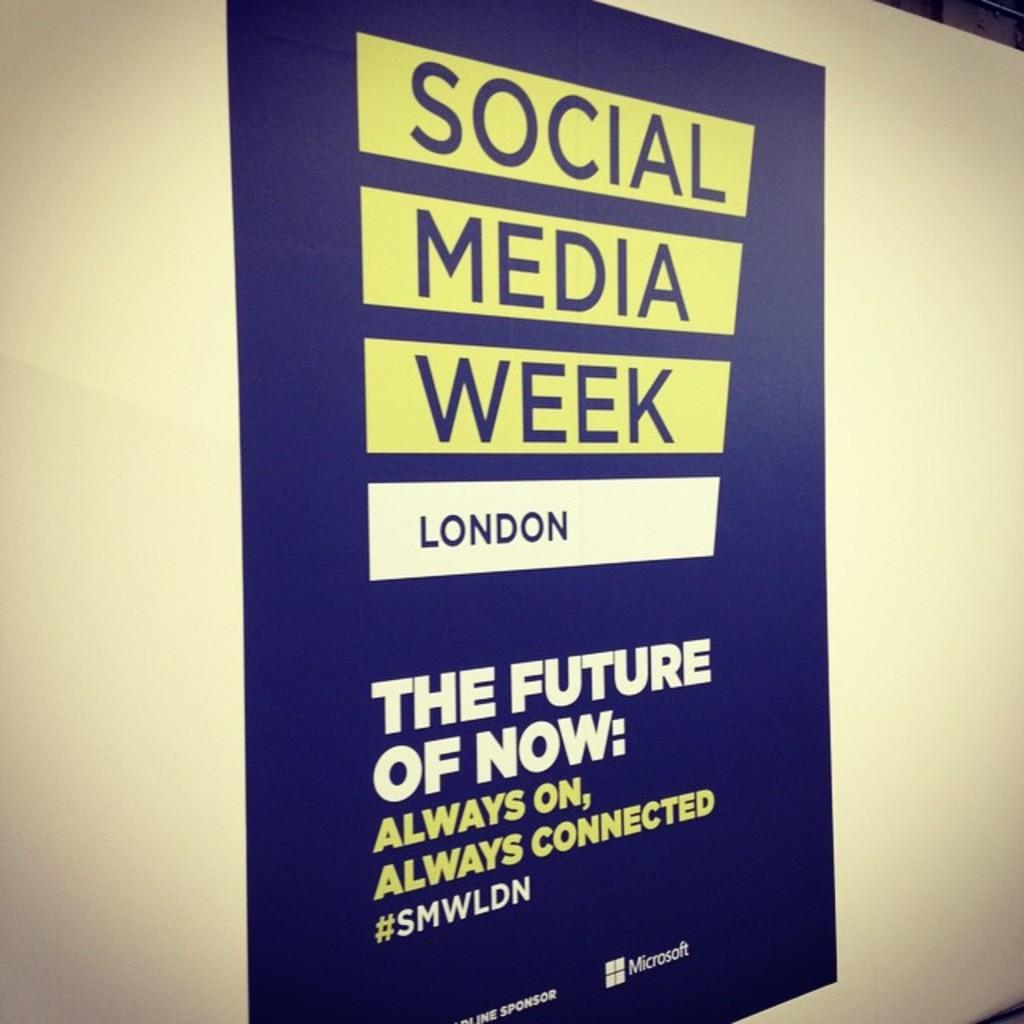<image>
Describe the image concisely. A poster on the wall advertises Social Media Week London. 